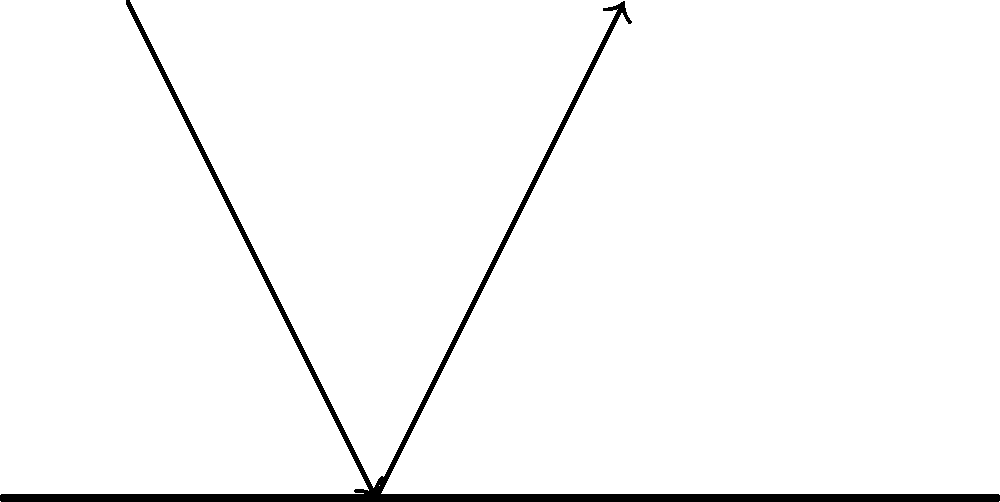In mirror therapy for phantom limb pain, light reflection plays a crucial role. Based on the diagram, what is the relationship between the angle of incidence ($\theta_i$) and the angle of reflection ($\theta_r$) when light reflects off the mirror surface? To understand the relationship between the angle of incidence and the angle of reflection in mirror therapy, let's follow these steps:

1. In the diagram, we can see an incident ray of light approaching the mirror surface.
2. The incident ray makes an angle $\theta_i$ with the normal (the line perpendicular to the mirror surface at the point of incidence).
3. After hitting the mirror surface, the light ray is reflected.
4. The reflected ray makes an angle $\theta_r$ with the normal.
5. According to the law of reflection in physics:
   a) The incident ray, the reflected ray, and the normal all lie in the same plane.
   b) The angle of incidence is equal to the angle of reflection.
6. This means that $\theta_i = \theta_r$.
7. In mirror therapy, this principle ensures that the reflection of the existing limb appears in a position that corresponds to where the phantom limb is perceived, creating a visual illusion that can help alleviate phantom limb pain.

Understanding this relationship is crucial for mental health professionals working with patients using mirror therapy, as it explains why the visual feedback is effective in tricking the brain and potentially reducing phantom limb sensations.
Answer: $\theta_i = \theta_r$ 